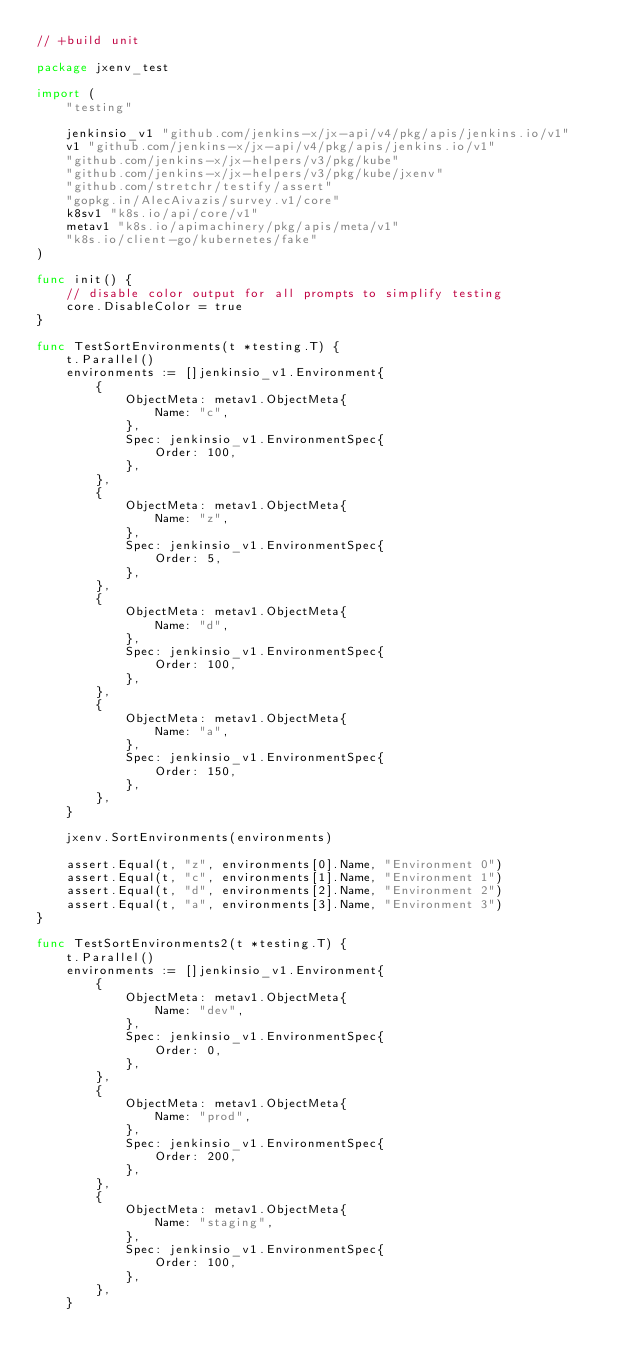<code> <loc_0><loc_0><loc_500><loc_500><_Go_>// +build unit

package jxenv_test

import (
	"testing"

	jenkinsio_v1 "github.com/jenkins-x/jx-api/v4/pkg/apis/jenkins.io/v1"
	v1 "github.com/jenkins-x/jx-api/v4/pkg/apis/jenkins.io/v1"
	"github.com/jenkins-x/jx-helpers/v3/pkg/kube"
	"github.com/jenkins-x/jx-helpers/v3/pkg/kube/jxenv"
	"github.com/stretchr/testify/assert"
	"gopkg.in/AlecAivazis/survey.v1/core"
	k8sv1 "k8s.io/api/core/v1"
	metav1 "k8s.io/apimachinery/pkg/apis/meta/v1"
	"k8s.io/client-go/kubernetes/fake"
)

func init() {
	// disable color output for all prompts to simplify testing
	core.DisableColor = true
}

func TestSortEnvironments(t *testing.T) {
	t.Parallel()
	environments := []jenkinsio_v1.Environment{
		{
			ObjectMeta: metav1.ObjectMeta{
				Name: "c",
			},
			Spec: jenkinsio_v1.EnvironmentSpec{
				Order: 100,
			},
		},
		{
			ObjectMeta: metav1.ObjectMeta{
				Name: "z",
			},
			Spec: jenkinsio_v1.EnvironmentSpec{
				Order: 5,
			},
		},
		{
			ObjectMeta: metav1.ObjectMeta{
				Name: "d",
			},
			Spec: jenkinsio_v1.EnvironmentSpec{
				Order: 100,
			},
		},
		{
			ObjectMeta: metav1.ObjectMeta{
				Name: "a",
			},
			Spec: jenkinsio_v1.EnvironmentSpec{
				Order: 150,
			},
		},
	}

	jxenv.SortEnvironments(environments)

	assert.Equal(t, "z", environments[0].Name, "Environment 0")
	assert.Equal(t, "c", environments[1].Name, "Environment 1")
	assert.Equal(t, "d", environments[2].Name, "Environment 2")
	assert.Equal(t, "a", environments[3].Name, "Environment 3")
}

func TestSortEnvironments2(t *testing.T) {
	t.Parallel()
	environments := []jenkinsio_v1.Environment{
		{
			ObjectMeta: metav1.ObjectMeta{
				Name: "dev",
			},
			Spec: jenkinsio_v1.EnvironmentSpec{
				Order: 0,
			},
		},
		{
			ObjectMeta: metav1.ObjectMeta{
				Name: "prod",
			},
			Spec: jenkinsio_v1.EnvironmentSpec{
				Order: 200,
			},
		},
		{
			ObjectMeta: metav1.ObjectMeta{
				Name: "staging",
			},
			Spec: jenkinsio_v1.EnvironmentSpec{
				Order: 100,
			},
		},
	}
</code> 